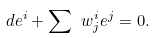<formula> <loc_0><loc_0><loc_500><loc_500>d e ^ { i } + \sum \ w ^ { i } _ { j } e ^ { j } = 0 .</formula> 